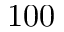<formula> <loc_0><loc_0><loc_500><loc_500>1 0 0</formula> 